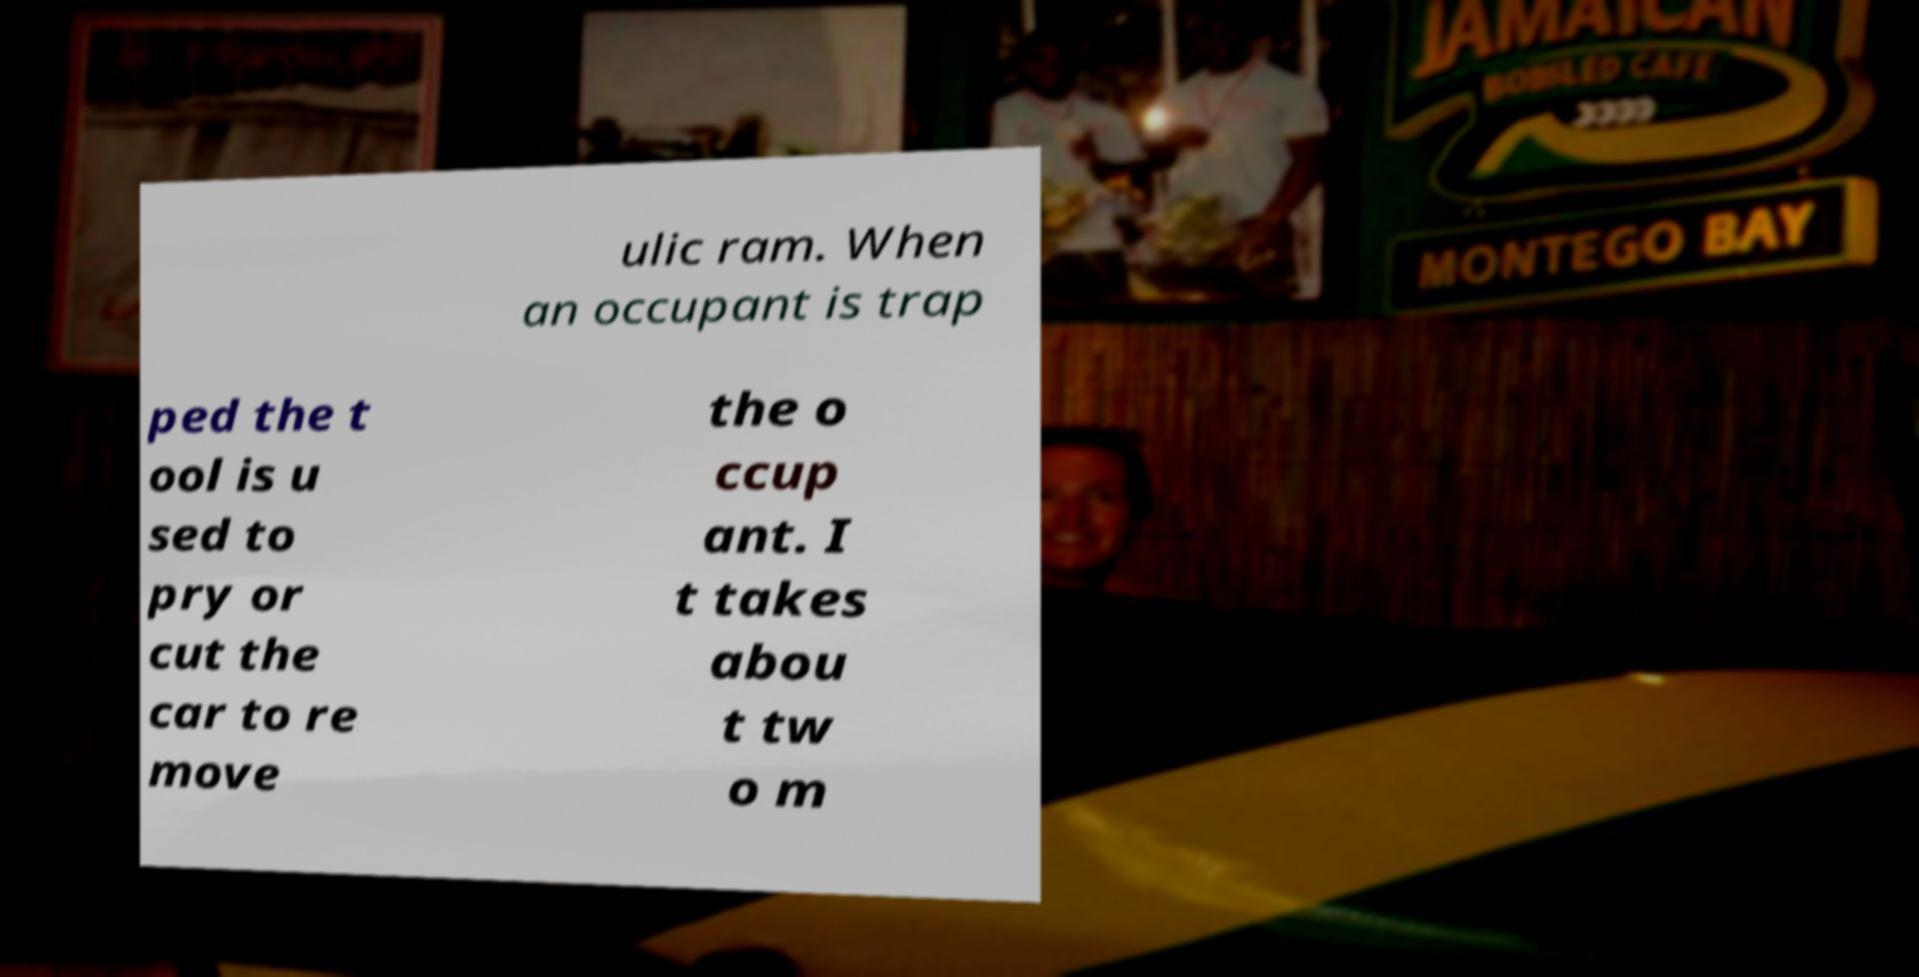Can you read and provide the text displayed in the image?This photo seems to have some interesting text. Can you extract and type it out for me? ulic ram. When an occupant is trap ped the t ool is u sed to pry or cut the car to re move the o ccup ant. I t takes abou t tw o m 